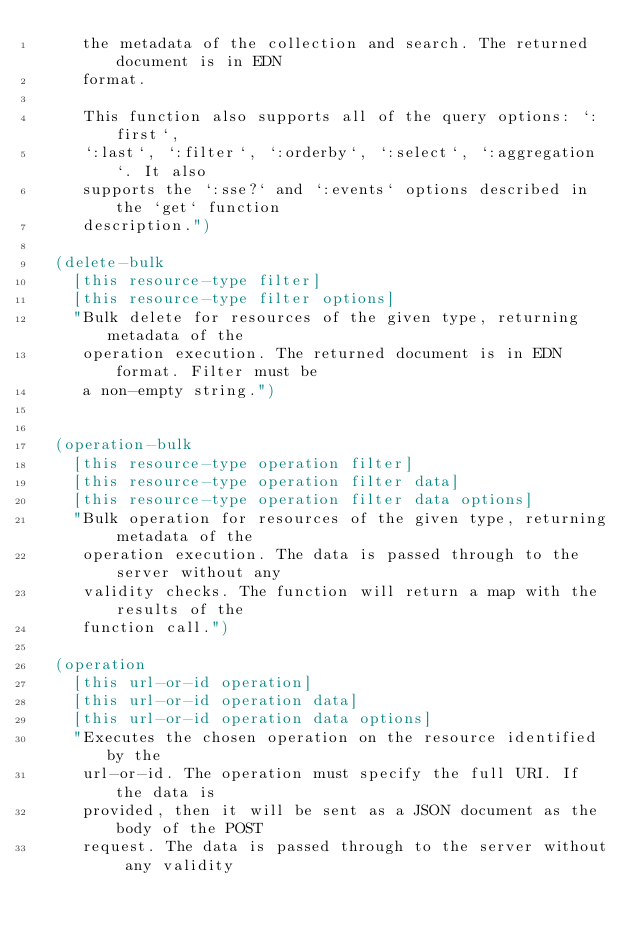<code> <loc_0><loc_0><loc_500><loc_500><_Clojure_>     the metadata of the collection and search. The returned document is in EDN
     format.

     This function also supports all of the query options: `:first`,
     `:last`, `:filter`, `:orderby`, `:select`, `:aggregation`. It also
     supports the `:sse?` and `:events` options described in the `get` function
     description.")

  (delete-bulk
    [this resource-type filter]
    [this resource-type filter options]
    "Bulk delete for resources of the given type, returning metadata of the
     operation execution. The returned document is in EDN format. Filter must be
     a non-empty string.")


  (operation-bulk
    [this resource-type operation filter]
    [this resource-type operation filter data]
    [this resource-type operation filter data options]
    "Bulk operation for resources of the given type, returning metadata of the
     operation execution. The data is passed through to the server without any
     validity checks. The function will return a map with the results of the
     function call.")

  (operation
    [this url-or-id operation]
    [this url-or-id operation data]
    [this url-or-id operation data options]
    "Executes the chosen operation on the resource identified by the
     url-or-id. The operation must specify the full URI. If the data is
     provided, then it will be sent as a JSON document as the body of the POST
     request. The data is passed through to the server without any validity</code> 